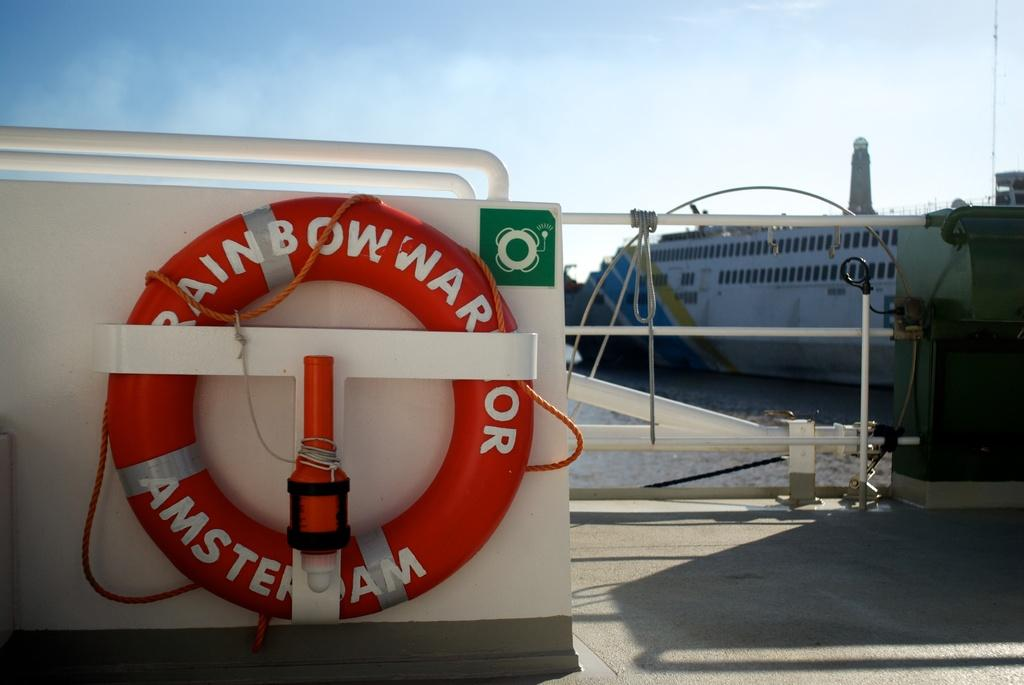<image>
Present a compact description of the photo's key features. A life preserver from Amsterdam is attached to a wall. 